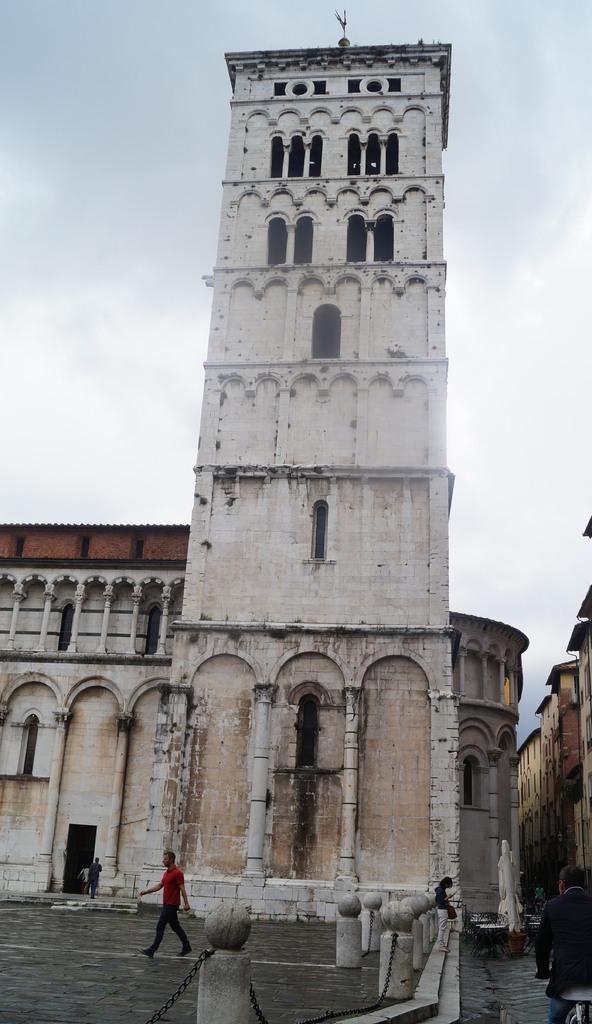How would you summarize this image in a sentence or two? In this image I can see a person walking wearing red color shirt. Background I can see a building in white and cream color and sky in white color. 